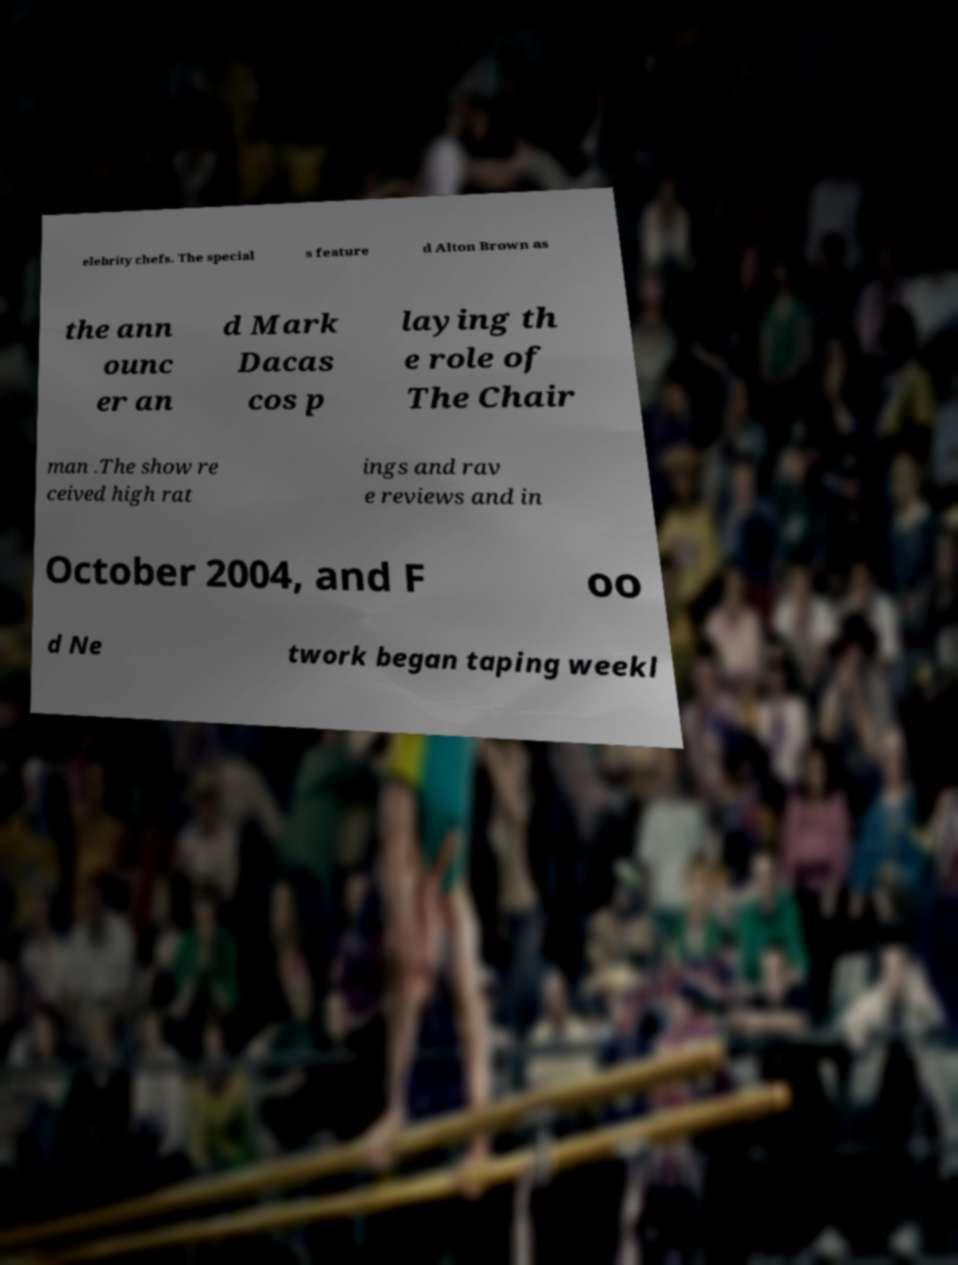For documentation purposes, I need the text within this image transcribed. Could you provide that? elebrity chefs. The special s feature d Alton Brown as the ann ounc er an d Mark Dacas cos p laying th e role of The Chair man .The show re ceived high rat ings and rav e reviews and in October 2004, and F oo d Ne twork began taping weekl 